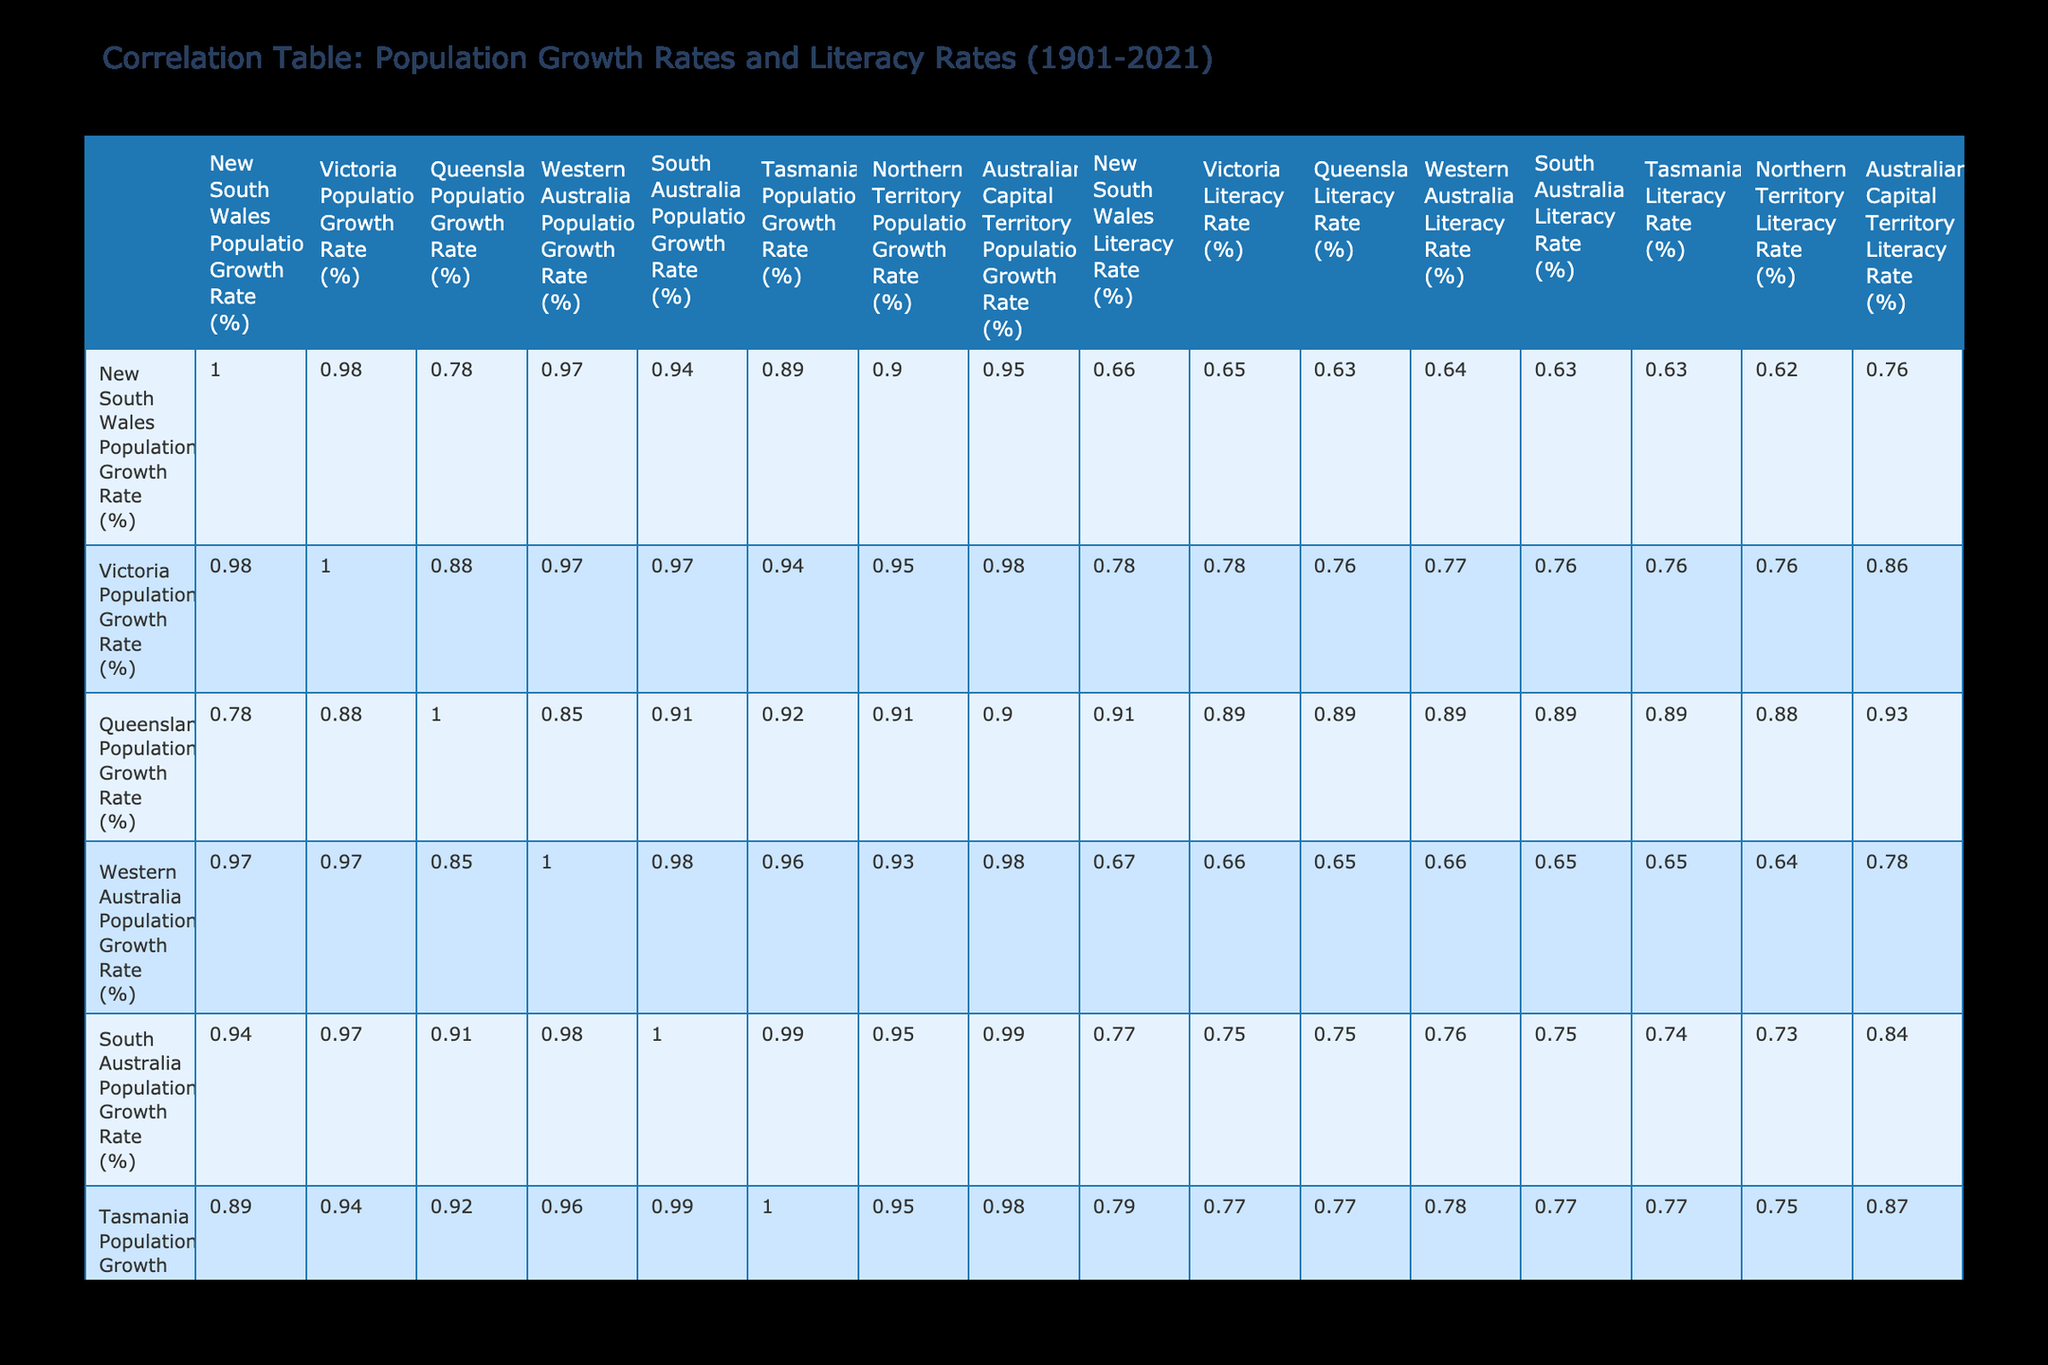What is the literacy rate in New South Wales in 2021? According to the table, the literacy rate in New South Wales in 2021 is listed as 99.8%.
Answer: 99.8 Which state had the highest population growth rate in 2001? From the table, Queensland had the highest population growth rate in 2001 at 2.80%.
Answer: 2.80 What was the average literacy rate for all states in 1941? The literacy rates in 1941 for all states are 75, 75, 74, 73, 74, 76, 70, and 72. Adding these values gives 594, and dividing by 8 gives an average of 74.25.
Answer: 74.25 Did the literacy rate in Tasmania increase from 1901 to 2021? Comparing the literacy rates in Tasmania, it was 50% in 1901 and increased to 90% in 2021. Thus, it did indeed increase over this period.
Answer: Yes Which state had the lowest population growth rate in 1981? The table shows South Australia had the lowest population growth rate in 1981 at 0.75%.
Answer: 0.75 What is the difference in literacy rates between Victoria and Queensland in 1961? In 1961, Victoria had a literacy rate of 88%, while Queensland had a rate of 89%. The difference is 89 - 88 = 1%.
Answer: 1 Which two states had a literacy rate greater than or equal to 90% in 2021? The table for 2021 shows New South Wales and Victoria both had literacy rates of 99.8% and 97% respectively, thus both surpassed 90%.
Answer: New South Wales, Victoria What is the trend in population growth rates for Tasmania from 1901 to 2021? The table shows that Tasmania's population growth rate increased from 0.45% in 1901 to 0.90% in 2021. Although it shows growth, it is notably lower than those of other states.
Answer: Increasing What year did Western Australia have the highest population growth rate? Checking the table, Western Australia had its highest growth rate in 2021 at 1.80%.
Answer: 2021 